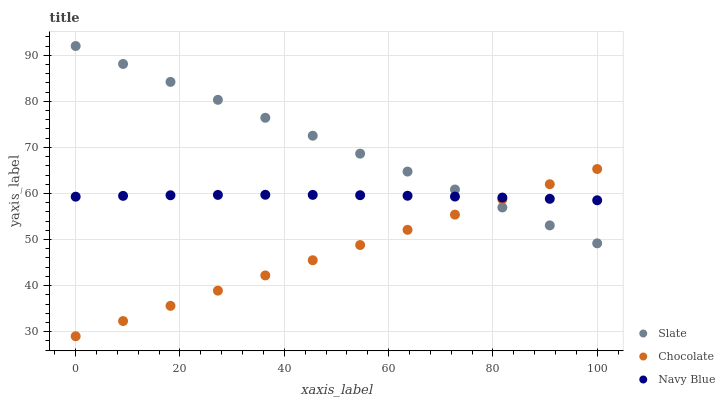Does Chocolate have the minimum area under the curve?
Answer yes or no. Yes. Does Slate have the maximum area under the curve?
Answer yes or no. Yes. Does Slate have the minimum area under the curve?
Answer yes or no. No. Does Chocolate have the maximum area under the curve?
Answer yes or no. No. Is Chocolate the smoothest?
Answer yes or no. Yes. Is Navy Blue the roughest?
Answer yes or no. Yes. Is Slate the smoothest?
Answer yes or no. No. Is Slate the roughest?
Answer yes or no. No. Does Chocolate have the lowest value?
Answer yes or no. Yes. Does Slate have the lowest value?
Answer yes or no. No. Does Slate have the highest value?
Answer yes or no. Yes. Does Chocolate have the highest value?
Answer yes or no. No. Does Chocolate intersect Slate?
Answer yes or no. Yes. Is Chocolate less than Slate?
Answer yes or no. No. Is Chocolate greater than Slate?
Answer yes or no. No. 